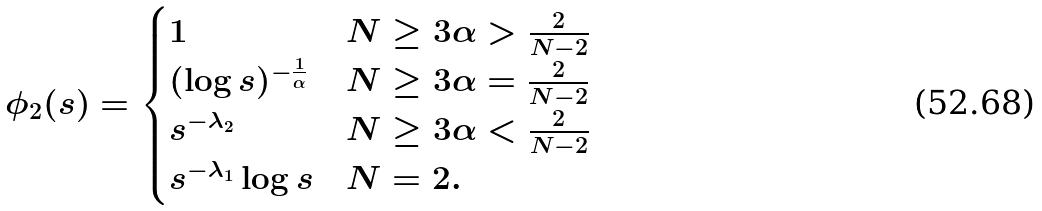<formula> <loc_0><loc_0><loc_500><loc_500>\phi _ { 2 } ( s ) = \begin{cases} 1 & N \geq 3 \alpha > \frac { 2 } { N - 2 } \\ ( \log s ) ^ { - \frac { 1 } { \alpha } } & N \geq 3 \alpha = \frac { 2 } { N - 2 } \\ s ^ { - \lambda _ { 2 } } & N \geq 3 \alpha < \frac { 2 } { N - 2 } \\ s ^ { - \lambda _ { 1 } } \log s & N = 2 . \end{cases}</formula> 